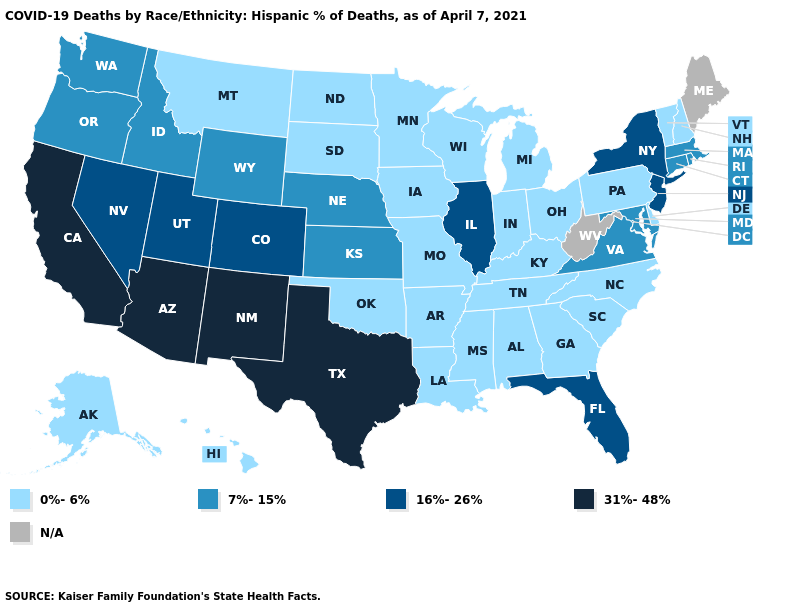Name the states that have a value in the range 7%-15%?
Quick response, please. Connecticut, Idaho, Kansas, Maryland, Massachusetts, Nebraska, Oregon, Rhode Island, Virginia, Washington, Wyoming. Does Vermont have the highest value in the Northeast?
Concise answer only. No. Name the states that have a value in the range 16%-26%?
Answer briefly. Colorado, Florida, Illinois, Nevada, New Jersey, New York, Utah. How many symbols are there in the legend?
Write a very short answer. 5. Among the states that border Nevada , does Idaho have the highest value?
Short answer required. No. What is the value of Wyoming?
Answer briefly. 7%-15%. Does the map have missing data?
Answer briefly. Yes. Name the states that have a value in the range 7%-15%?
Short answer required. Connecticut, Idaho, Kansas, Maryland, Massachusetts, Nebraska, Oregon, Rhode Island, Virginia, Washington, Wyoming. Does Maryland have the highest value in the USA?
Short answer required. No. What is the value of West Virginia?
Keep it brief. N/A. Does Michigan have the lowest value in the USA?
Answer briefly. Yes. Name the states that have a value in the range 31%-48%?
Keep it brief. Arizona, California, New Mexico, Texas. What is the highest value in the West ?
Short answer required. 31%-48%. Does the map have missing data?
Quick response, please. Yes. 